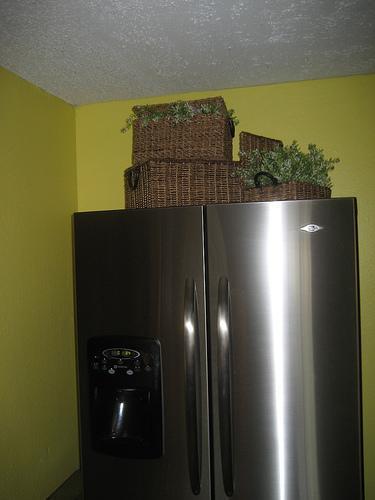How many baskets are open?
Give a very brief answer. 1. 